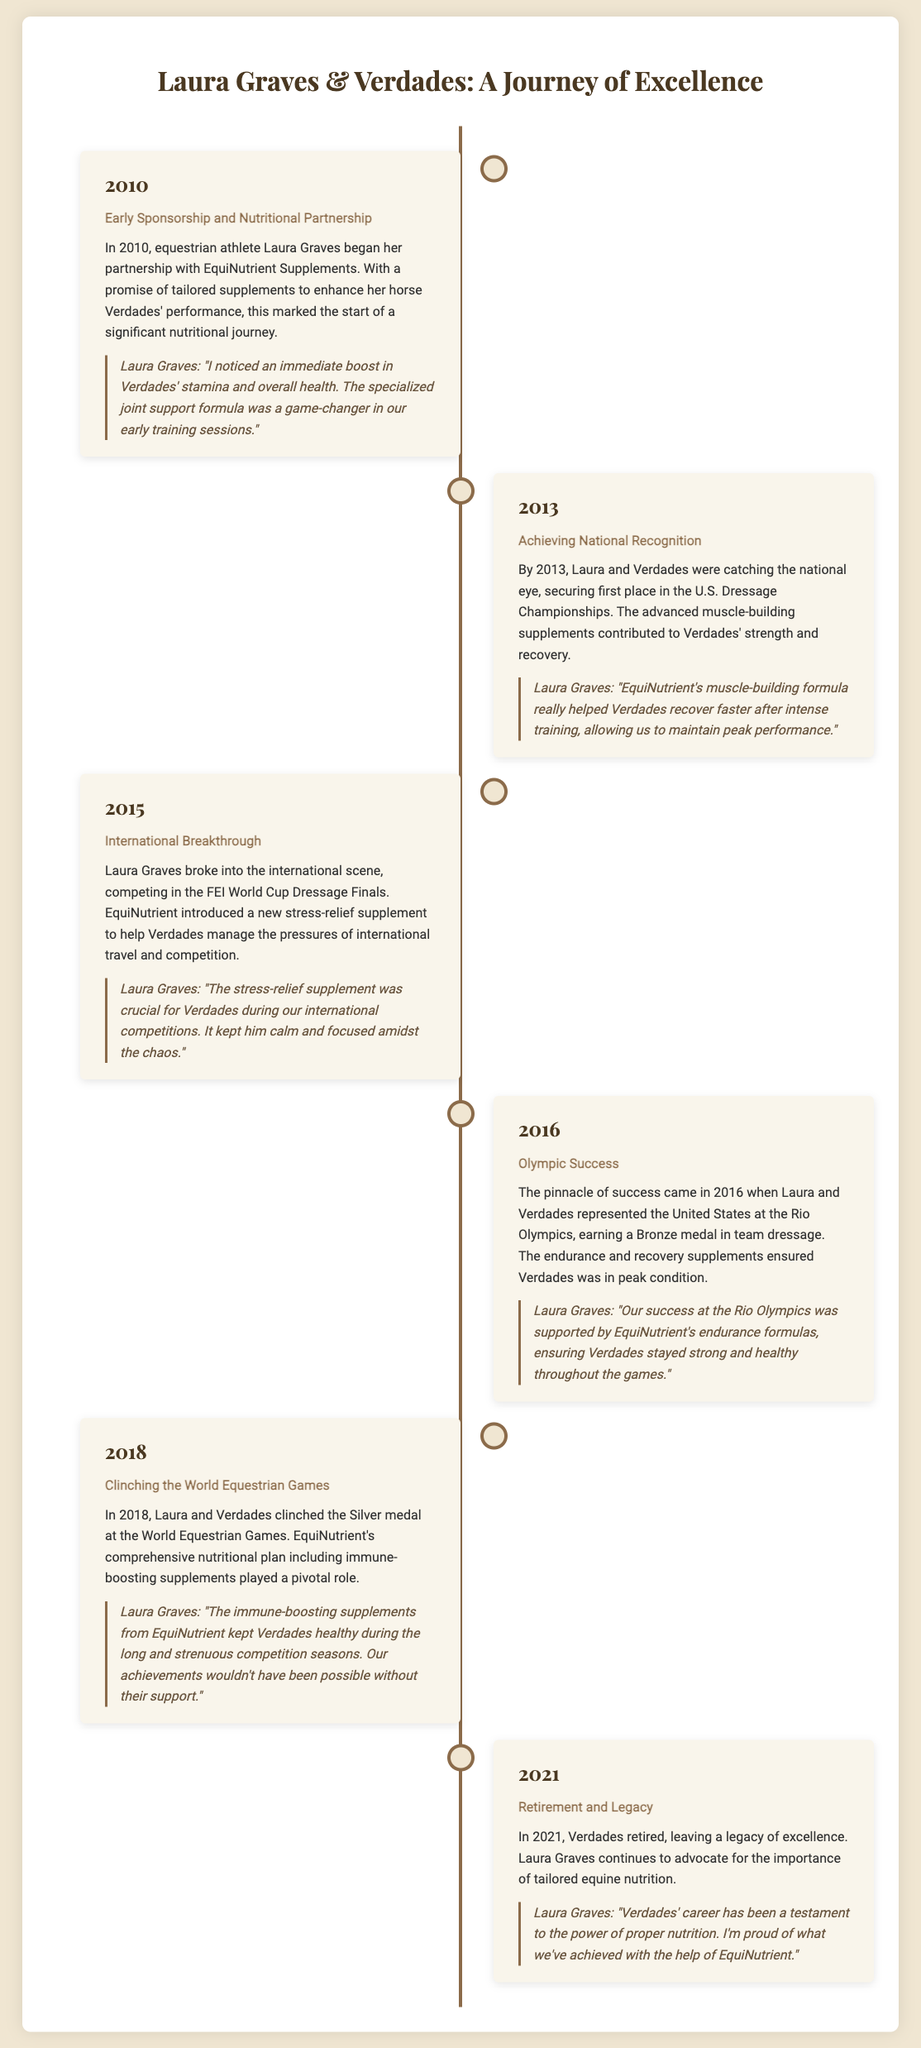what year did Laura Graves start her partnership with EquiNutrient Supplements? The document states that Laura Graves began her partnership in 2010.
Answer: 2010 what achievement did Laura and Verdades secure in 2013? The document mentions that they secured first place in the U.S. Dressage Championships.
Answer: First place in the U.S. Dressage Championships which international competition did Laura Graves compete in during 2015? According to the document, Laura competed in the FEI World Cup Dressage Finals in 2015.
Answer: FEI World Cup Dressage Finals what medal did Laura and Verdades earn at the Rio Olympics? The document indicates that they earned a Bronze medal in team dressage.
Answer: Bronze medal what type of supplement did EquiNutrient introduce in 2015? The document states that a new stress-relief supplement was introduced to help Verdades.
Answer: Stress-relief supplement how did Laura describe the impact of EquiNutrient's endurance formulas in 2016? Laura mentions that it ensured Verdades stayed strong and healthy throughout the games.
Answer: Stayed strong and healthy what significant event occurred for Verdades in 2021? The document states that Verdades retired in 2021.
Answer: Retirement how did Laura Graves feel about EquiNutrient's support throughout her journey? Laura expressed pride in their achievements with EquiNutrient's help.
Answer: Proud of what we've achieved 